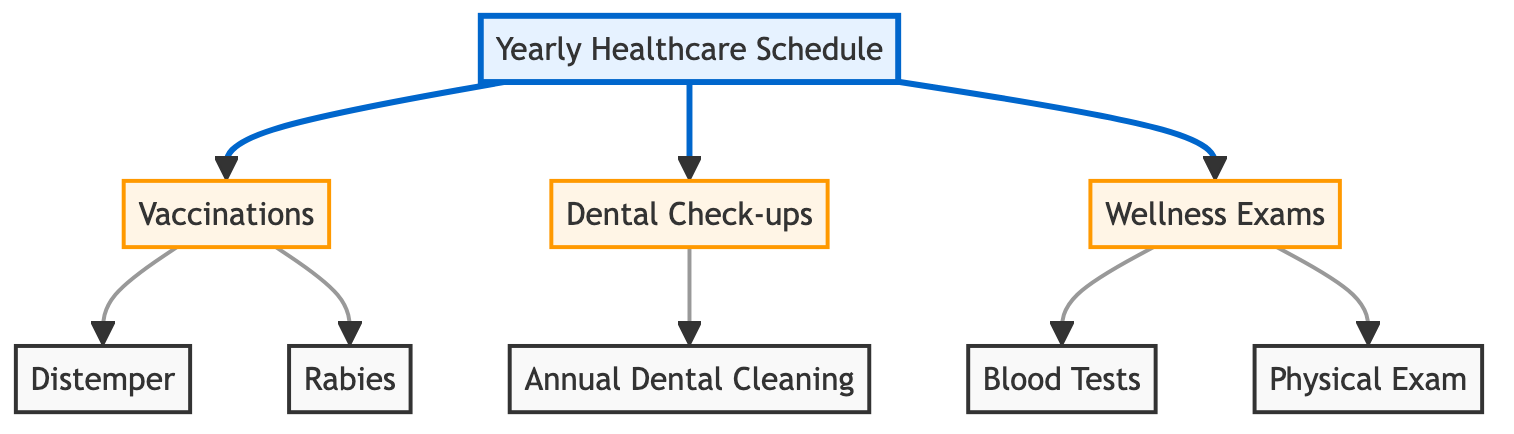What are the three main categories in the yearly healthcare schedule? The diagram shows three primary branches from the "Yearly Healthcare Schedule" node: "Vaccinations," "Dental Check-ups," and "Wellness Exams." Each of these branches represents a key area of healthcare for senior pets.
Answer: Vaccinations, Dental Check-ups, Wellness Exams How many vaccinations are listed in the diagram? Under the "Vaccinations" node, there are two sub-nodes: "Distemper" and "Rabies." This indicates that there are two vaccinations outlined in the yearly schedule.
Answer: 2 What is one of the components under Dental Check-ups? The "Dental Check-ups" node branches to "Annual Dental Cleaning." This indicates that one key action is scheduled under this category.
Answer: Annual Dental Cleaning Which wellness exam includes blood tests? The "Wellness Exams" node has two sub-components, one of which is "Blood Tests." This means that blood tests are part of the wellness exam category.
Answer: Blood Tests What is the relationship between Wellness Exams and Physical Exam? "Wellness Exams" is connected to "Physical Exam," suggesting that a physical exam is one of the procedures included in the wellness exams for senior pets.
Answer: Physical Exam How many total nodes are connected to the Yearly Healthcare Schedule? Starting from the "Yearly Healthcare Schedule" node, it connects to three main branches: "Vaccinations," "Dental Check-ups," and "Wellness Exams." There are also further sub-nodes leading from these categories. Counting all connected nodes gives a total of six.
Answer: 6 What is one reason for a pet to have a dental check-up? The diagram indicates that one of the reasons for dental check-ups is to undergo "Annual Dental Cleaning," signifying its importance in regular pet care.
Answer: Annual Dental Cleaning Which vaccination is related to rabies? "Rabies" is listed as one of the vaccinations under the "Vaccinations" branch, which is intended for protection against the rabies virus.
Answer: Rabies 